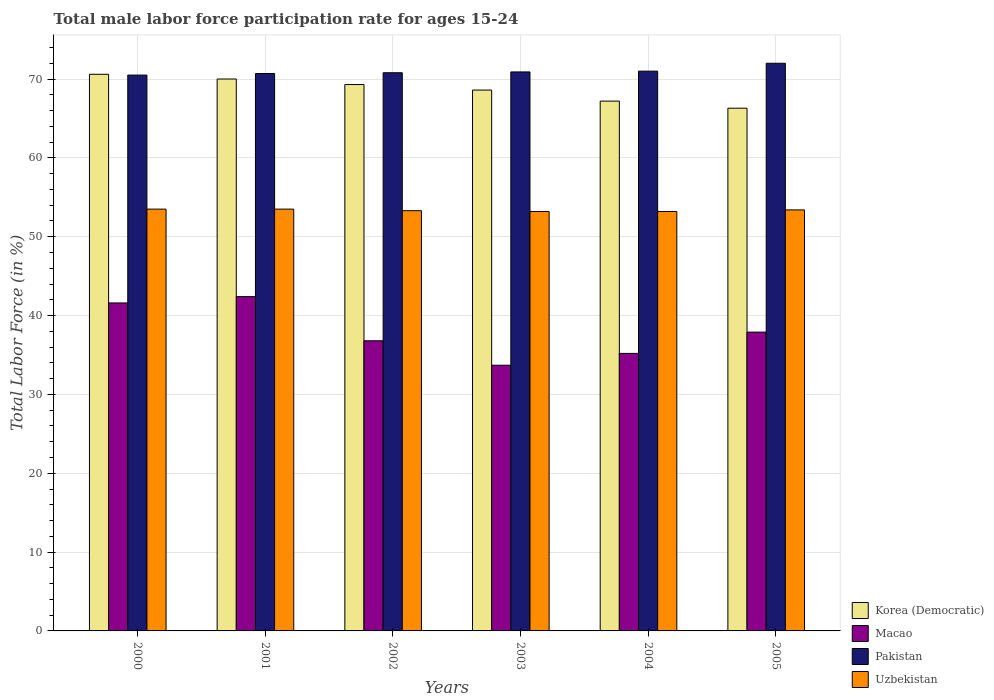Are the number of bars on each tick of the X-axis equal?
Give a very brief answer. Yes. How many bars are there on the 1st tick from the left?
Make the answer very short. 4. How many bars are there on the 1st tick from the right?
Offer a very short reply. 4. What is the label of the 1st group of bars from the left?
Provide a short and direct response. 2000. What is the male labor force participation rate in Korea (Democratic) in 2003?
Your answer should be very brief. 68.6. Across all years, what is the maximum male labor force participation rate in Macao?
Offer a very short reply. 42.4. Across all years, what is the minimum male labor force participation rate in Uzbekistan?
Provide a succinct answer. 53.2. In which year was the male labor force participation rate in Uzbekistan maximum?
Give a very brief answer. 2000. What is the total male labor force participation rate in Macao in the graph?
Your answer should be very brief. 227.6. What is the difference between the male labor force participation rate in Uzbekistan in 2002 and that in 2004?
Give a very brief answer. 0.1. What is the difference between the male labor force participation rate in Korea (Democratic) in 2000 and the male labor force participation rate in Pakistan in 2003?
Make the answer very short. -0.3. What is the average male labor force participation rate in Pakistan per year?
Provide a short and direct response. 70.98. In the year 2005, what is the difference between the male labor force participation rate in Uzbekistan and male labor force participation rate in Pakistan?
Your response must be concise. -18.6. In how many years, is the male labor force participation rate in Pakistan greater than 60 %?
Ensure brevity in your answer.  6. What is the ratio of the male labor force participation rate in Uzbekistan in 2000 to that in 2005?
Your answer should be compact. 1. What is the difference between the highest and the lowest male labor force participation rate in Uzbekistan?
Give a very brief answer. 0.3. What does the 4th bar from the left in 2003 represents?
Your answer should be compact. Uzbekistan. Are all the bars in the graph horizontal?
Keep it short and to the point. No. How many years are there in the graph?
Provide a short and direct response. 6. Are the values on the major ticks of Y-axis written in scientific E-notation?
Give a very brief answer. No. What is the title of the graph?
Give a very brief answer. Total male labor force participation rate for ages 15-24. Does "Least developed countries" appear as one of the legend labels in the graph?
Offer a very short reply. No. What is the label or title of the X-axis?
Provide a succinct answer. Years. What is the label or title of the Y-axis?
Offer a very short reply. Total Labor Force (in %). What is the Total Labor Force (in %) in Korea (Democratic) in 2000?
Provide a short and direct response. 70.6. What is the Total Labor Force (in %) of Macao in 2000?
Offer a very short reply. 41.6. What is the Total Labor Force (in %) of Pakistan in 2000?
Your response must be concise. 70.5. What is the Total Labor Force (in %) in Uzbekistan in 2000?
Your answer should be very brief. 53.5. What is the Total Labor Force (in %) in Korea (Democratic) in 2001?
Your response must be concise. 70. What is the Total Labor Force (in %) of Macao in 2001?
Give a very brief answer. 42.4. What is the Total Labor Force (in %) of Pakistan in 2001?
Make the answer very short. 70.7. What is the Total Labor Force (in %) in Uzbekistan in 2001?
Your response must be concise. 53.5. What is the Total Labor Force (in %) of Korea (Democratic) in 2002?
Offer a terse response. 69.3. What is the Total Labor Force (in %) in Macao in 2002?
Give a very brief answer. 36.8. What is the Total Labor Force (in %) in Pakistan in 2002?
Your response must be concise. 70.8. What is the Total Labor Force (in %) in Uzbekistan in 2002?
Keep it short and to the point. 53.3. What is the Total Labor Force (in %) in Korea (Democratic) in 2003?
Give a very brief answer. 68.6. What is the Total Labor Force (in %) of Macao in 2003?
Provide a short and direct response. 33.7. What is the Total Labor Force (in %) in Pakistan in 2003?
Provide a succinct answer. 70.9. What is the Total Labor Force (in %) in Uzbekistan in 2003?
Keep it short and to the point. 53.2. What is the Total Labor Force (in %) in Korea (Democratic) in 2004?
Ensure brevity in your answer.  67.2. What is the Total Labor Force (in %) in Macao in 2004?
Ensure brevity in your answer.  35.2. What is the Total Labor Force (in %) of Uzbekistan in 2004?
Your answer should be compact. 53.2. What is the Total Labor Force (in %) in Korea (Democratic) in 2005?
Provide a short and direct response. 66.3. What is the Total Labor Force (in %) of Macao in 2005?
Make the answer very short. 37.9. What is the Total Labor Force (in %) of Uzbekistan in 2005?
Offer a terse response. 53.4. Across all years, what is the maximum Total Labor Force (in %) of Korea (Democratic)?
Keep it short and to the point. 70.6. Across all years, what is the maximum Total Labor Force (in %) of Macao?
Offer a terse response. 42.4. Across all years, what is the maximum Total Labor Force (in %) of Uzbekistan?
Ensure brevity in your answer.  53.5. Across all years, what is the minimum Total Labor Force (in %) in Korea (Democratic)?
Your response must be concise. 66.3. Across all years, what is the minimum Total Labor Force (in %) in Macao?
Provide a succinct answer. 33.7. Across all years, what is the minimum Total Labor Force (in %) in Pakistan?
Make the answer very short. 70.5. Across all years, what is the minimum Total Labor Force (in %) of Uzbekistan?
Your answer should be compact. 53.2. What is the total Total Labor Force (in %) of Korea (Democratic) in the graph?
Keep it short and to the point. 412. What is the total Total Labor Force (in %) of Macao in the graph?
Give a very brief answer. 227.6. What is the total Total Labor Force (in %) in Pakistan in the graph?
Provide a short and direct response. 425.9. What is the total Total Labor Force (in %) of Uzbekistan in the graph?
Provide a succinct answer. 320.1. What is the difference between the Total Labor Force (in %) of Korea (Democratic) in 2000 and that in 2001?
Provide a succinct answer. 0.6. What is the difference between the Total Labor Force (in %) in Macao in 2000 and that in 2001?
Your response must be concise. -0.8. What is the difference between the Total Labor Force (in %) of Pakistan in 2000 and that in 2002?
Offer a very short reply. -0.3. What is the difference between the Total Labor Force (in %) of Uzbekistan in 2000 and that in 2002?
Ensure brevity in your answer.  0.2. What is the difference between the Total Labor Force (in %) of Korea (Democratic) in 2000 and that in 2003?
Your response must be concise. 2. What is the difference between the Total Labor Force (in %) of Macao in 2000 and that in 2003?
Give a very brief answer. 7.9. What is the difference between the Total Labor Force (in %) of Uzbekistan in 2000 and that in 2003?
Your answer should be very brief. 0.3. What is the difference between the Total Labor Force (in %) in Korea (Democratic) in 2000 and that in 2004?
Provide a succinct answer. 3.4. What is the difference between the Total Labor Force (in %) in Pakistan in 2000 and that in 2004?
Your answer should be compact. -0.5. What is the difference between the Total Labor Force (in %) of Pakistan in 2000 and that in 2005?
Your response must be concise. -1.5. What is the difference between the Total Labor Force (in %) in Korea (Democratic) in 2001 and that in 2002?
Offer a very short reply. 0.7. What is the difference between the Total Labor Force (in %) in Macao in 2001 and that in 2002?
Your response must be concise. 5.6. What is the difference between the Total Labor Force (in %) in Uzbekistan in 2001 and that in 2003?
Offer a terse response. 0.3. What is the difference between the Total Labor Force (in %) of Korea (Democratic) in 2001 and that in 2004?
Give a very brief answer. 2.8. What is the difference between the Total Labor Force (in %) in Macao in 2001 and that in 2004?
Ensure brevity in your answer.  7.2. What is the difference between the Total Labor Force (in %) of Uzbekistan in 2001 and that in 2004?
Offer a very short reply. 0.3. What is the difference between the Total Labor Force (in %) of Korea (Democratic) in 2001 and that in 2005?
Keep it short and to the point. 3.7. What is the difference between the Total Labor Force (in %) of Uzbekistan in 2001 and that in 2005?
Ensure brevity in your answer.  0.1. What is the difference between the Total Labor Force (in %) of Pakistan in 2002 and that in 2003?
Offer a very short reply. -0.1. What is the difference between the Total Labor Force (in %) in Pakistan in 2002 and that in 2004?
Give a very brief answer. -0.2. What is the difference between the Total Labor Force (in %) of Uzbekistan in 2002 and that in 2004?
Your answer should be very brief. 0.1. What is the difference between the Total Labor Force (in %) in Macao in 2002 and that in 2005?
Offer a terse response. -1.1. What is the difference between the Total Labor Force (in %) in Pakistan in 2002 and that in 2005?
Offer a terse response. -1.2. What is the difference between the Total Labor Force (in %) in Korea (Democratic) in 2003 and that in 2004?
Provide a succinct answer. 1.4. What is the difference between the Total Labor Force (in %) in Macao in 2003 and that in 2004?
Your response must be concise. -1.5. What is the difference between the Total Labor Force (in %) of Pakistan in 2003 and that in 2005?
Ensure brevity in your answer.  -1.1. What is the difference between the Total Labor Force (in %) in Korea (Democratic) in 2004 and that in 2005?
Your answer should be compact. 0.9. What is the difference between the Total Labor Force (in %) in Pakistan in 2004 and that in 2005?
Give a very brief answer. -1. What is the difference between the Total Labor Force (in %) in Uzbekistan in 2004 and that in 2005?
Keep it short and to the point. -0.2. What is the difference between the Total Labor Force (in %) in Korea (Democratic) in 2000 and the Total Labor Force (in %) in Macao in 2001?
Ensure brevity in your answer.  28.2. What is the difference between the Total Labor Force (in %) in Korea (Democratic) in 2000 and the Total Labor Force (in %) in Pakistan in 2001?
Your answer should be compact. -0.1. What is the difference between the Total Labor Force (in %) of Macao in 2000 and the Total Labor Force (in %) of Pakistan in 2001?
Give a very brief answer. -29.1. What is the difference between the Total Labor Force (in %) of Macao in 2000 and the Total Labor Force (in %) of Uzbekistan in 2001?
Your answer should be compact. -11.9. What is the difference between the Total Labor Force (in %) in Pakistan in 2000 and the Total Labor Force (in %) in Uzbekistan in 2001?
Ensure brevity in your answer.  17. What is the difference between the Total Labor Force (in %) in Korea (Democratic) in 2000 and the Total Labor Force (in %) in Macao in 2002?
Provide a short and direct response. 33.8. What is the difference between the Total Labor Force (in %) in Korea (Democratic) in 2000 and the Total Labor Force (in %) in Pakistan in 2002?
Give a very brief answer. -0.2. What is the difference between the Total Labor Force (in %) in Macao in 2000 and the Total Labor Force (in %) in Pakistan in 2002?
Ensure brevity in your answer.  -29.2. What is the difference between the Total Labor Force (in %) in Pakistan in 2000 and the Total Labor Force (in %) in Uzbekistan in 2002?
Provide a short and direct response. 17.2. What is the difference between the Total Labor Force (in %) of Korea (Democratic) in 2000 and the Total Labor Force (in %) of Macao in 2003?
Ensure brevity in your answer.  36.9. What is the difference between the Total Labor Force (in %) in Korea (Democratic) in 2000 and the Total Labor Force (in %) in Pakistan in 2003?
Offer a very short reply. -0.3. What is the difference between the Total Labor Force (in %) of Korea (Democratic) in 2000 and the Total Labor Force (in %) of Uzbekistan in 2003?
Your answer should be compact. 17.4. What is the difference between the Total Labor Force (in %) in Macao in 2000 and the Total Labor Force (in %) in Pakistan in 2003?
Offer a terse response. -29.3. What is the difference between the Total Labor Force (in %) in Korea (Democratic) in 2000 and the Total Labor Force (in %) in Macao in 2004?
Offer a very short reply. 35.4. What is the difference between the Total Labor Force (in %) of Korea (Democratic) in 2000 and the Total Labor Force (in %) of Pakistan in 2004?
Offer a terse response. -0.4. What is the difference between the Total Labor Force (in %) of Macao in 2000 and the Total Labor Force (in %) of Pakistan in 2004?
Your response must be concise. -29.4. What is the difference between the Total Labor Force (in %) of Pakistan in 2000 and the Total Labor Force (in %) of Uzbekistan in 2004?
Give a very brief answer. 17.3. What is the difference between the Total Labor Force (in %) of Korea (Democratic) in 2000 and the Total Labor Force (in %) of Macao in 2005?
Ensure brevity in your answer.  32.7. What is the difference between the Total Labor Force (in %) of Korea (Democratic) in 2000 and the Total Labor Force (in %) of Pakistan in 2005?
Your answer should be compact. -1.4. What is the difference between the Total Labor Force (in %) in Macao in 2000 and the Total Labor Force (in %) in Pakistan in 2005?
Your response must be concise. -30.4. What is the difference between the Total Labor Force (in %) of Korea (Democratic) in 2001 and the Total Labor Force (in %) of Macao in 2002?
Provide a succinct answer. 33.2. What is the difference between the Total Labor Force (in %) of Korea (Democratic) in 2001 and the Total Labor Force (in %) of Uzbekistan in 2002?
Give a very brief answer. 16.7. What is the difference between the Total Labor Force (in %) in Macao in 2001 and the Total Labor Force (in %) in Pakistan in 2002?
Your response must be concise. -28.4. What is the difference between the Total Labor Force (in %) in Korea (Democratic) in 2001 and the Total Labor Force (in %) in Macao in 2003?
Offer a terse response. 36.3. What is the difference between the Total Labor Force (in %) of Macao in 2001 and the Total Labor Force (in %) of Pakistan in 2003?
Give a very brief answer. -28.5. What is the difference between the Total Labor Force (in %) in Macao in 2001 and the Total Labor Force (in %) in Uzbekistan in 2003?
Provide a short and direct response. -10.8. What is the difference between the Total Labor Force (in %) in Pakistan in 2001 and the Total Labor Force (in %) in Uzbekistan in 2003?
Provide a short and direct response. 17.5. What is the difference between the Total Labor Force (in %) of Korea (Democratic) in 2001 and the Total Labor Force (in %) of Macao in 2004?
Your response must be concise. 34.8. What is the difference between the Total Labor Force (in %) in Korea (Democratic) in 2001 and the Total Labor Force (in %) in Uzbekistan in 2004?
Give a very brief answer. 16.8. What is the difference between the Total Labor Force (in %) in Macao in 2001 and the Total Labor Force (in %) in Pakistan in 2004?
Make the answer very short. -28.6. What is the difference between the Total Labor Force (in %) in Pakistan in 2001 and the Total Labor Force (in %) in Uzbekistan in 2004?
Offer a very short reply. 17.5. What is the difference between the Total Labor Force (in %) of Korea (Democratic) in 2001 and the Total Labor Force (in %) of Macao in 2005?
Your answer should be compact. 32.1. What is the difference between the Total Labor Force (in %) in Korea (Democratic) in 2001 and the Total Labor Force (in %) in Uzbekistan in 2005?
Your answer should be compact. 16.6. What is the difference between the Total Labor Force (in %) in Macao in 2001 and the Total Labor Force (in %) in Pakistan in 2005?
Offer a terse response. -29.6. What is the difference between the Total Labor Force (in %) of Pakistan in 2001 and the Total Labor Force (in %) of Uzbekistan in 2005?
Provide a succinct answer. 17.3. What is the difference between the Total Labor Force (in %) in Korea (Democratic) in 2002 and the Total Labor Force (in %) in Macao in 2003?
Your response must be concise. 35.6. What is the difference between the Total Labor Force (in %) in Korea (Democratic) in 2002 and the Total Labor Force (in %) in Pakistan in 2003?
Provide a short and direct response. -1.6. What is the difference between the Total Labor Force (in %) of Korea (Democratic) in 2002 and the Total Labor Force (in %) of Uzbekistan in 2003?
Provide a short and direct response. 16.1. What is the difference between the Total Labor Force (in %) in Macao in 2002 and the Total Labor Force (in %) in Pakistan in 2003?
Give a very brief answer. -34.1. What is the difference between the Total Labor Force (in %) in Macao in 2002 and the Total Labor Force (in %) in Uzbekistan in 2003?
Ensure brevity in your answer.  -16.4. What is the difference between the Total Labor Force (in %) in Korea (Democratic) in 2002 and the Total Labor Force (in %) in Macao in 2004?
Keep it short and to the point. 34.1. What is the difference between the Total Labor Force (in %) of Macao in 2002 and the Total Labor Force (in %) of Pakistan in 2004?
Provide a short and direct response. -34.2. What is the difference between the Total Labor Force (in %) of Macao in 2002 and the Total Labor Force (in %) of Uzbekistan in 2004?
Your answer should be compact. -16.4. What is the difference between the Total Labor Force (in %) in Pakistan in 2002 and the Total Labor Force (in %) in Uzbekistan in 2004?
Offer a very short reply. 17.6. What is the difference between the Total Labor Force (in %) of Korea (Democratic) in 2002 and the Total Labor Force (in %) of Macao in 2005?
Your answer should be compact. 31.4. What is the difference between the Total Labor Force (in %) of Korea (Democratic) in 2002 and the Total Labor Force (in %) of Uzbekistan in 2005?
Provide a succinct answer. 15.9. What is the difference between the Total Labor Force (in %) in Macao in 2002 and the Total Labor Force (in %) in Pakistan in 2005?
Your answer should be compact. -35.2. What is the difference between the Total Labor Force (in %) of Macao in 2002 and the Total Labor Force (in %) of Uzbekistan in 2005?
Keep it short and to the point. -16.6. What is the difference between the Total Labor Force (in %) in Korea (Democratic) in 2003 and the Total Labor Force (in %) in Macao in 2004?
Ensure brevity in your answer.  33.4. What is the difference between the Total Labor Force (in %) of Korea (Democratic) in 2003 and the Total Labor Force (in %) of Pakistan in 2004?
Your response must be concise. -2.4. What is the difference between the Total Labor Force (in %) of Macao in 2003 and the Total Labor Force (in %) of Pakistan in 2004?
Provide a short and direct response. -37.3. What is the difference between the Total Labor Force (in %) in Macao in 2003 and the Total Labor Force (in %) in Uzbekistan in 2004?
Provide a succinct answer. -19.5. What is the difference between the Total Labor Force (in %) in Pakistan in 2003 and the Total Labor Force (in %) in Uzbekistan in 2004?
Give a very brief answer. 17.7. What is the difference between the Total Labor Force (in %) of Korea (Democratic) in 2003 and the Total Labor Force (in %) of Macao in 2005?
Give a very brief answer. 30.7. What is the difference between the Total Labor Force (in %) in Macao in 2003 and the Total Labor Force (in %) in Pakistan in 2005?
Provide a short and direct response. -38.3. What is the difference between the Total Labor Force (in %) of Macao in 2003 and the Total Labor Force (in %) of Uzbekistan in 2005?
Ensure brevity in your answer.  -19.7. What is the difference between the Total Labor Force (in %) in Pakistan in 2003 and the Total Labor Force (in %) in Uzbekistan in 2005?
Offer a very short reply. 17.5. What is the difference between the Total Labor Force (in %) in Korea (Democratic) in 2004 and the Total Labor Force (in %) in Macao in 2005?
Provide a short and direct response. 29.3. What is the difference between the Total Labor Force (in %) of Korea (Democratic) in 2004 and the Total Labor Force (in %) of Uzbekistan in 2005?
Your answer should be very brief. 13.8. What is the difference between the Total Labor Force (in %) of Macao in 2004 and the Total Labor Force (in %) of Pakistan in 2005?
Keep it short and to the point. -36.8. What is the difference between the Total Labor Force (in %) of Macao in 2004 and the Total Labor Force (in %) of Uzbekistan in 2005?
Provide a succinct answer. -18.2. What is the difference between the Total Labor Force (in %) of Pakistan in 2004 and the Total Labor Force (in %) of Uzbekistan in 2005?
Your answer should be very brief. 17.6. What is the average Total Labor Force (in %) in Korea (Democratic) per year?
Your answer should be compact. 68.67. What is the average Total Labor Force (in %) of Macao per year?
Your answer should be compact. 37.93. What is the average Total Labor Force (in %) in Pakistan per year?
Make the answer very short. 70.98. What is the average Total Labor Force (in %) in Uzbekistan per year?
Keep it short and to the point. 53.35. In the year 2000, what is the difference between the Total Labor Force (in %) of Macao and Total Labor Force (in %) of Pakistan?
Offer a terse response. -28.9. In the year 2000, what is the difference between the Total Labor Force (in %) in Macao and Total Labor Force (in %) in Uzbekistan?
Offer a terse response. -11.9. In the year 2001, what is the difference between the Total Labor Force (in %) of Korea (Democratic) and Total Labor Force (in %) of Macao?
Your response must be concise. 27.6. In the year 2001, what is the difference between the Total Labor Force (in %) of Macao and Total Labor Force (in %) of Pakistan?
Provide a short and direct response. -28.3. In the year 2001, what is the difference between the Total Labor Force (in %) of Macao and Total Labor Force (in %) of Uzbekistan?
Your response must be concise. -11.1. In the year 2001, what is the difference between the Total Labor Force (in %) of Pakistan and Total Labor Force (in %) of Uzbekistan?
Ensure brevity in your answer.  17.2. In the year 2002, what is the difference between the Total Labor Force (in %) in Korea (Democratic) and Total Labor Force (in %) in Macao?
Make the answer very short. 32.5. In the year 2002, what is the difference between the Total Labor Force (in %) of Korea (Democratic) and Total Labor Force (in %) of Pakistan?
Give a very brief answer. -1.5. In the year 2002, what is the difference between the Total Labor Force (in %) in Macao and Total Labor Force (in %) in Pakistan?
Your answer should be very brief. -34. In the year 2002, what is the difference between the Total Labor Force (in %) of Macao and Total Labor Force (in %) of Uzbekistan?
Offer a terse response. -16.5. In the year 2003, what is the difference between the Total Labor Force (in %) of Korea (Democratic) and Total Labor Force (in %) of Macao?
Your answer should be very brief. 34.9. In the year 2003, what is the difference between the Total Labor Force (in %) in Macao and Total Labor Force (in %) in Pakistan?
Keep it short and to the point. -37.2. In the year 2003, what is the difference between the Total Labor Force (in %) of Macao and Total Labor Force (in %) of Uzbekistan?
Your answer should be very brief. -19.5. In the year 2003, what is the difference between the Total Labor Force (in %) in Pakistan and Total Labor Force (in %) in Uzbekistan?
Keep it short and to the point. 17.7. In the year 2004, what is the difference between the Total Labor Force (in %) of Korea (Democratic) and Total Labor Force (in %) of Pakistan?
Your response must be concise. -3.8. In the year 2004, what is the difference between the Total Labor Force (in %) of Korea (Democratic) and Total Labor Force (in %) of Uzbekistan?
Make the answer very short. 14. In the year 2004, what is the difference between the Total Labor Force (in %) in Macao and Total Labor Force (in %) in Pakistan?
Keep it short and to the point. -35.8. In the year 2004, what is the difference between the Total Labor Force (in %) of Macao and Total Labor Force (in %) of Uzbekistan?
Make the answer very short. -18. In the year 2005, what is the difference between the Total Labor Force (in %) of Korea (Democratic) and Total Labor Force (in %) of Macao?
Ensure brevity in your answer.  28.4. In the year 2005, what is the difference between the Total Labor Force (in %) in Korea (Democratic) and Total Labor Force (in %) in Pakistan?
Keep it short and to the point. -5.7. In the year 2005, what is the difference between the Total Labor Force (in %) of Korea (Democratic) and Total Labor Force (in %) of Uzbekistan?
Make the answer very short. 12.9. In the year 2005, what is the difference between the Total Labor Force (in %) in Macao and Total Labor Force (in %) in Pakistan?
Provide a short and direct response. -34.1. In the year 2005, what is the difference between the Total Labor Force (in %) of Macao and Total Labor Force (in %) of Uzbekistan?
Make the answer very short. -15.5. In the year 2005, what is the difference between the Total Labor Force (in %) in Pakistan and Total Labor Force (in %) in Uzbekistan?
Keep it short and to the point. 18.6. What is the ratio of the Total Labor Force (in %) in Korea (Democratic) in 2000 to that in 2001?
Your answer should be very brief. 1.01. What is the ratio of the Total Labor Force (in %) in Macao in 2000 to that in 2001?
Your response must be concise. 0.98. What is the ratio of the Total Labor Force (in %) in Pakistan in 2000 to that in 2001?
Give a very brief answer. 1. What is the ratio of the Total Labor Force (in %) of Uzbekistan in 2000 to that in 2001?
Give a very brief answer. 1. What is the ratio of the Total Labor Force (in %) in Korea (Democratic) in 2000 to that in 2002?
Make the answer very short. 1.02. What is the ratio of the Total Labor Force (in %) in Macao in 2000 to that in 2002?
Provide a short and direct response. 1.13. What is the ratio of the Total Labor Force (in %) of Korea (Democratic) in 2000 to that in 2003?
Your response must be concise. 1.03. What is the ratio of the Total Labor Force (in %) of Macao in 2000 to that in 2003?
Keep it short and to the point. 1.23. What is the ratio of the Total Labor Force (in %) of Pakistan in 2000 to that in 2003?
Make the answer very short. 0.99. What is the ratio of the Total Labor Force (in %) in Uzbekistan in 2000 to that in 2003?
Your answer should be very brief. 1.01. What is the ratio of the Total Labor Force (in %) in Korea (Democratic) in 2000 to that in 2004?
Make the answer very short. 1.05. What is the ratio of the Total Labor Force (in %) of Macao in 2000 to that in 2004?
Make the answer very short. 1.18. What is the ratio of the Total Labor Force (in %) of Pakistan in 2000 to that in 2004?
Give a very brief answer. 0.99. What is the ratio of the Total Labor Force (in %) in Uzbekistan in 2000 to that in 2004?
Ensure brevity in your answer.  1.01. What is the ratio of the Total Labor Force (in %) in Korea (Democratic) in 2000 to that in 2005?
Your response must be concise. 1.06. What is the ratio of the Total Labor Force (in %) of Macao in 2000 to that in 2005?
Offer a terse response. 1.1. What is the ratio of the Total Labor Force (in %) of Pakistan in 2000 to that in 2005?
Ensure brevity in your answer.  0.98. What is the ratio of the Total Labor Force (in %) of Uzbekistan in 2000 to that in 2005?
Offer a very short reply. 1. What is the ratio of the Total Labor Force (in %) in Macao in 2001 to that in 2002?
Give a very brief answer. 1.15. What is the ratio of the Total Labor Force (in %) of Uzbekistan in 2001 to that in 2002?
Provide a succinct answer. 1. What is the ratio of the Total Labor Force (in %) of Korea (Democratic) in 2001 to that in 2003?
Your answer should be very brief. 1.02. What is the ratio of the Total Labor Force (in %) in Macao in 2001 to that in 2003?
Make the answer very short. 1.26. What is the ratio of the Total Labor Force (in %) in Uzbekistan in 2001 to that in 2003?
Ensure brevity in your answer.  1.01. What is the ratio of the Total Labor Force (in %) in Korea (Democratic) in 2001 to that in 2004?
Provide a short and direct response. 1.04. What is the ratio of the Total Labor Force (in %) of Macao in 2001 to that in 2004?
Give a very brief answer. 1.2. What is the ratio of the Total Labor Force (in %) of Uzbekistan in 2001 to that in 2004?
Ensure brevity in your answer.  1.01. What is the ratio of the Total Labor Force (in %) in Korea (Democratic) in 2001 to that in 2005?
Make the answer very short. 1.06. What is the ratio of the Total Labor Force (in %) of Macao in 2001 to that in 2005?
Offer a terse response. 1.12. What is the ratio of the Total Labor Force (in %) in Pakistan in 2001 to that in 2005?
Make the answer very short. 0.98. What is the ratio of the Total Labor Force (in %) of Korea (Democratic) in 2002 to that in 2003?
Provide a succinct answer. 1.01. What is the ratio of the Total Labor Force (in %) in Macao in 2002 to that in 2003?
Make the answer very short. 1.09. What is the ratio of the Total Labor Force (in %) in Pakistan in 2002 to that in 2003?
Provide a succinct answer. 1. What is the ratio of the Total Labor Force (in %) of Uzbekistan in 2002 to that in 2003?
Your response must be concise. 1. What is the ratio of the Total Labor Force (in %) of Korea (Democratic) in 2002 to that in 2004?
Your answer should be very brief. 1.03. What is the ratio of the Total Labor Force (in %) in Macao in 2002 to that in 2004?
Make the answer very short. 1.05. What is the ratio of the Total Labor Force (in %) of Pakistan in 2002 to that in 2004?
Provide a succinct answer. 1. What is the ratio of the Total Labor Force (in %) in Uzbekistan in 2002 to that in 2004?
Offer a terse response. 1. What is the ratio of the Total Labor Force (in %) in Korea (Democratic) in 2002 to that in 2005?
Give a very brief answer. 1.05. What is the ratio of the Total Labor Force (in %) of Pakistan in 2002 to that in 2005?
Provide a short and direct response. 0.98. What is the ratio of the Total Labor Force (in %) in Korea (Democratic) in 2003 to that in 2004?
Give a very brief answer. 1.02. What is the ratio of the Total Labor Force (in %) of Macao in 2003 to that in 2004?
Your answer should be very brief. 0.96. What is the ratio of the Total Labor Force (in %) of Korea (Democratic) in 2003 to that in 2005?
Give a very brief answer. 1.03. What is the ratio of the Total Labor Force (in %) of Macao in 2003 to that in 2005?
Provide a short and direct response. 0.89. What is the ratio of the Total Labor Force (in %) of Pakistan in 2003 to that in 2005?
Your answer should be very brief. 0.98. What is the ratio of the Total Labor Force (in %) in Korea (Democratic) in 2004 to that in 2005?
Your answer should be very brief. 1.01. What is the ratio of the Total Labor Force (in %) of Macao in 2004 to that in 2005?
Provide a succinct answer. 0.93. What is the ratio of the Total Labor Force (in %) in Pakistan in 2004 to that in 2005?
Your answer should be very brief. 0.99. What is the ratio of the Total Labor Force (in %) of Uzbekistan in 2004 to that in 2005?
Give a very brief answer. 1. What is the difference between the highest and the second highest Total Labor Force (in %) of Korea (Democratic)?
Your response must be concise. 0.6. What is the difference between the highest and the second highest Total Labor Force (in %) of Pakistan?
Offer a terse response. 1. What is the difference between the highest and the lowest Total Labor Force (in %) in Korea (Democratic)?
Provide a succinct answer. 4.3. What is the difference between the highest and the lowest Total Labor Force (in %) of Macao?
Offer a terse response. 8.7. 